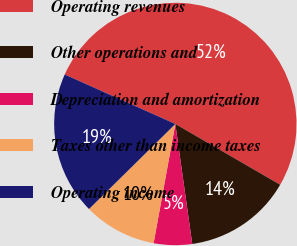Convert chart to OTSL. <chart><loc_0><loc_0><loc_500><loc_500><pie_chart><fcel>Operating revenues<fcel>Other operations and<fcel>Depreciation and amortization<fcel>Taxes other than income taxes<fcel>Operating income<nl><fcel>51.67%<fcel>14.41%<fcel>5.1%<fcel>9.75%<fcel>19.07%<nl></chart> 